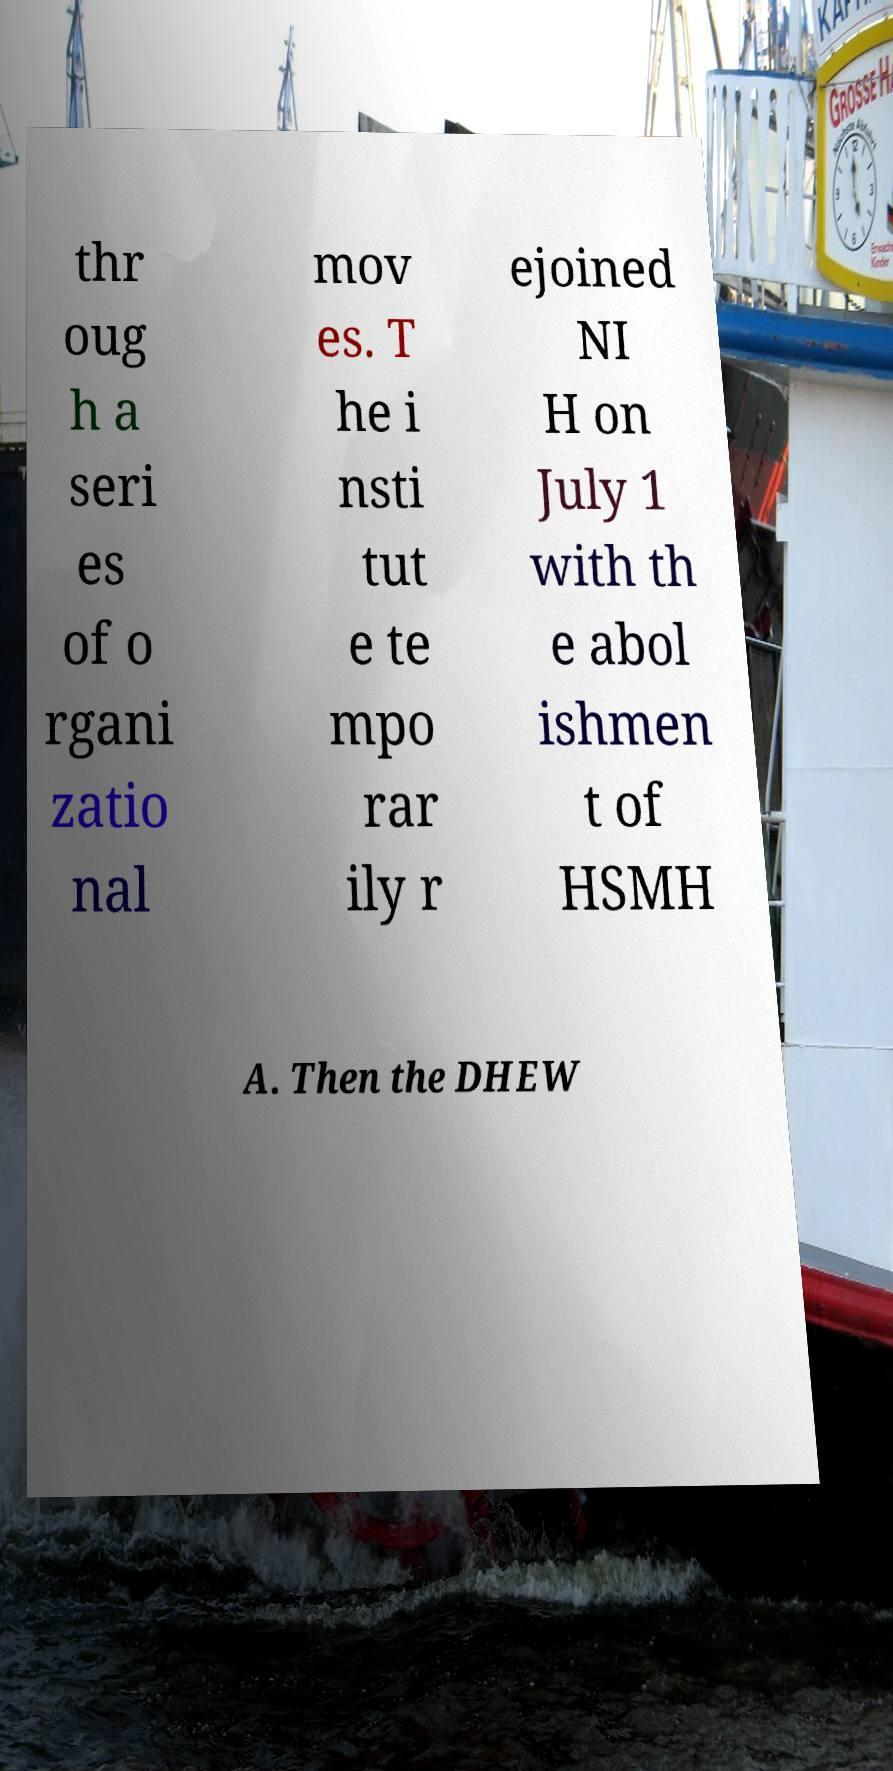For documentation purposes, I need the text within this image transcribed. Could you provide that? thr oug h a seri es of o rgani zatio nal mov es. T he i nsti tut e te mpo rar ily r ejoined NI H on July 1 with th e abol ishmen t of HSMH A. Then the DHEW 